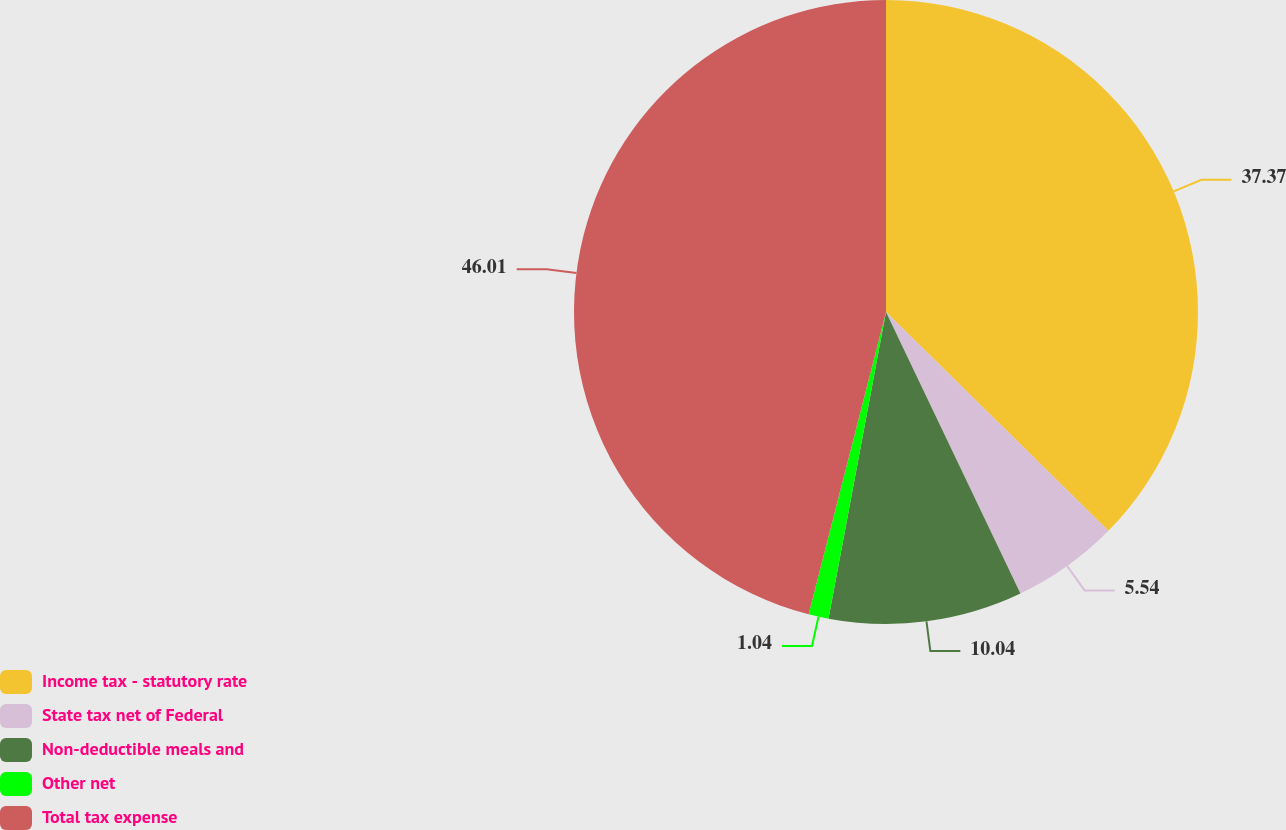Convert chart. <chart><loc_0><loc_0><loc_500><loc_500><pie_chart><fcel>Income tax - statutory rate<fcel>State tax net of Federal<fcel>Non-deductible meals and<fcel>Other net<fcel>Total tax expense<nl><fcel>37.37%<fcel>5.54%<fcel>10.04%<fcel>1.04%<fcel>46.01%<nl></chart> 